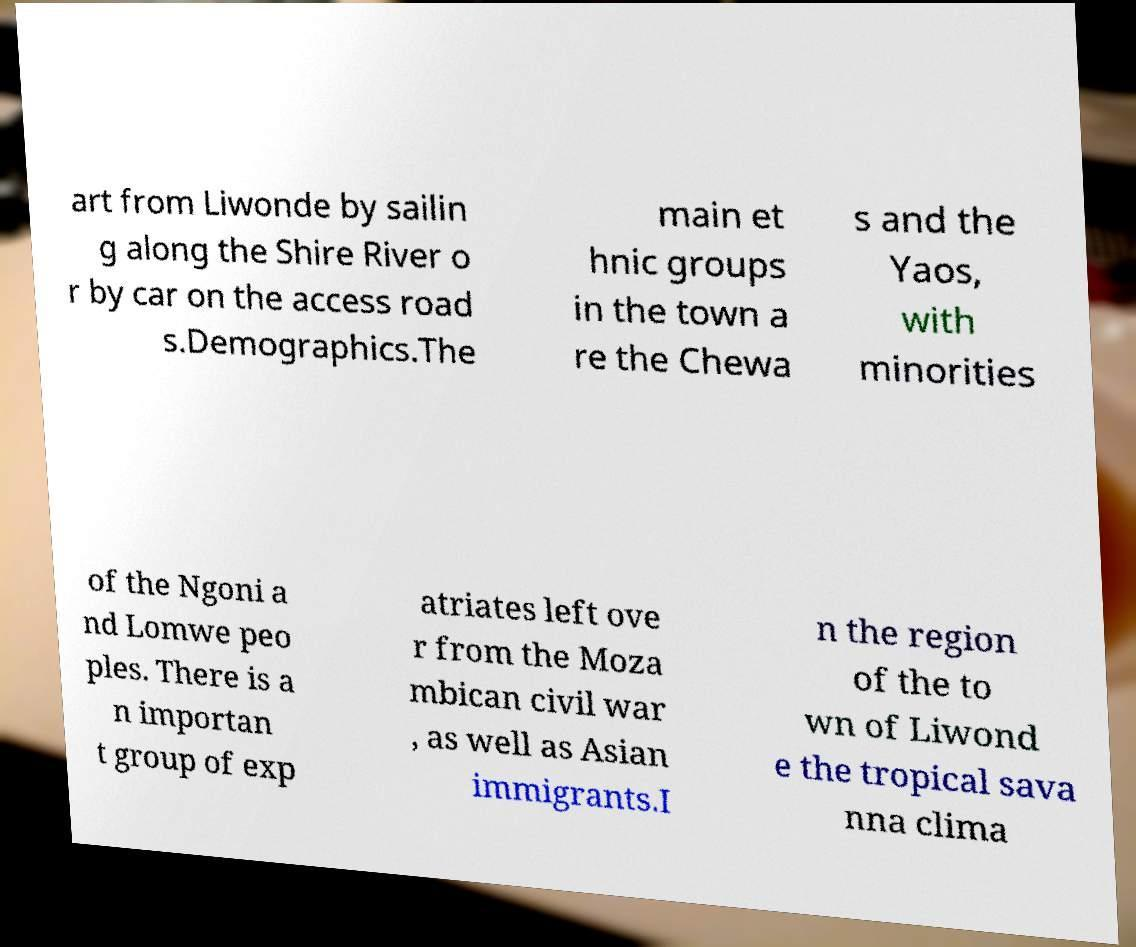What messages or text are displayed in this image? I need them in a readable, typed format. art from Liwonde by sailin g along the Shire River o r by car on the access road s.Demographics.The main et hnic groups in the town a re the Chewa s and the Yaos, with minorities of the Ngoni a nd Lomwe peo ples. There is a n importan t group of exp atriates left ove r from the Moza mbican civil war , as well as Asian immigrants.I n the region of the to wn of Liwond e the tropical sava nna clima 